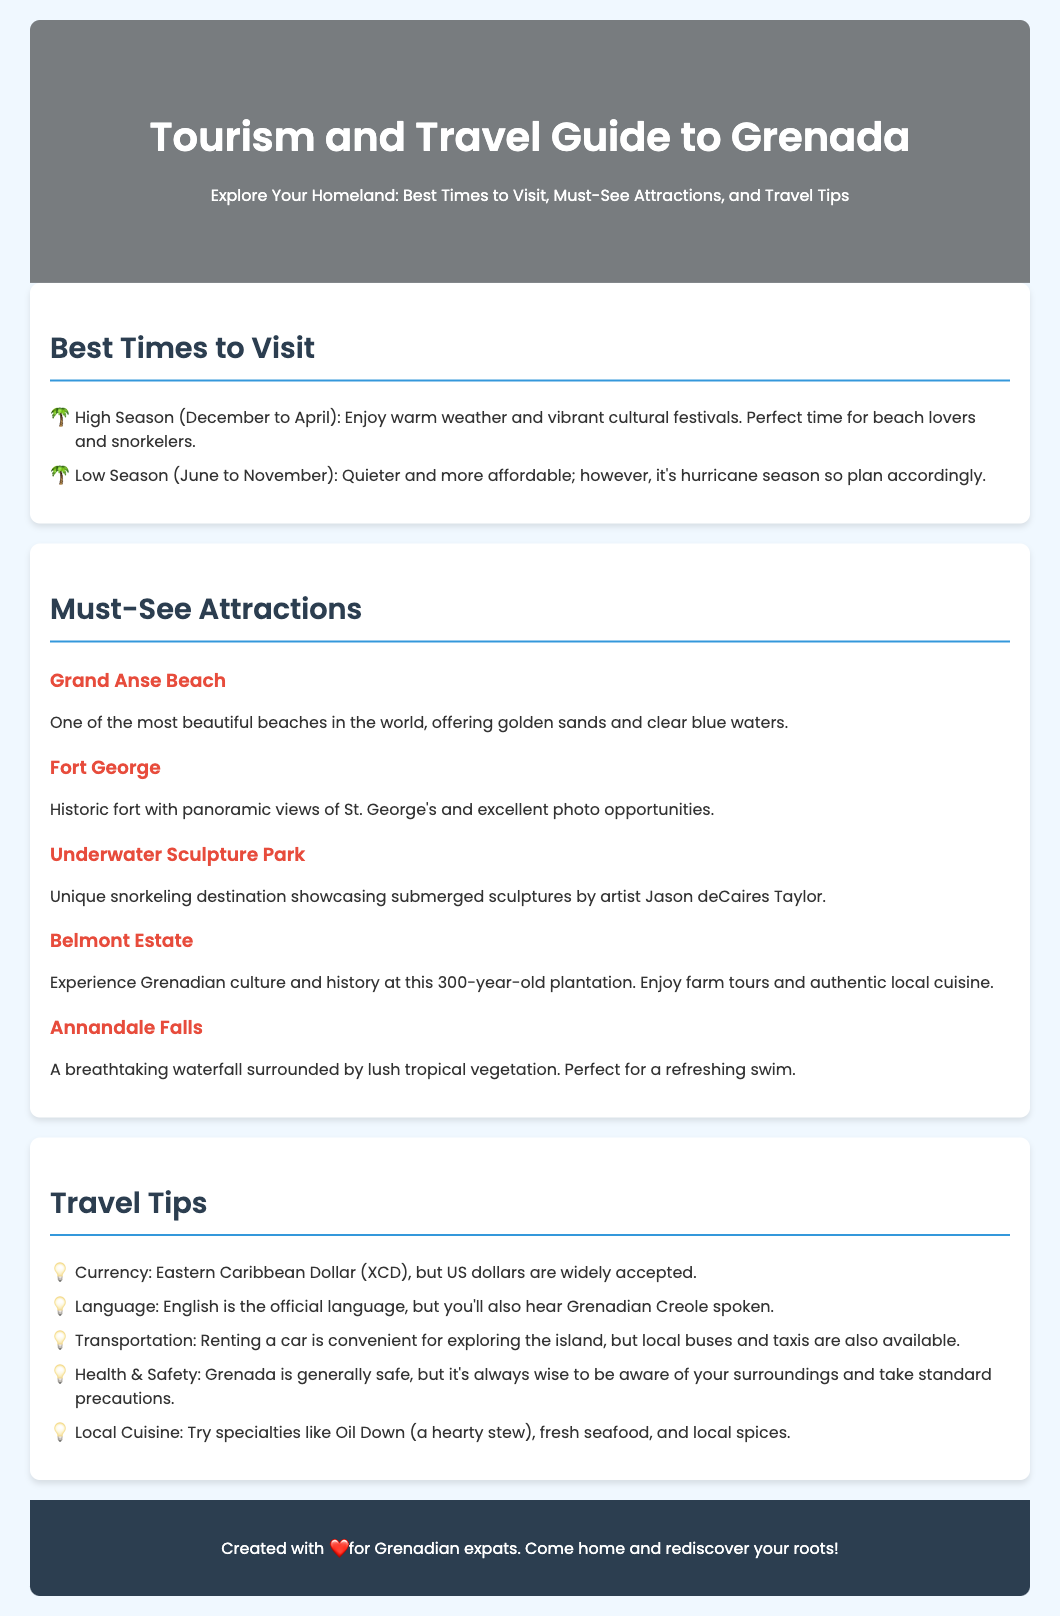What is the high season for visiting Grenada? The high season is from December to April when warm weather and vibrant cultural festivals occur.
Answer: December to April Which beach is noted as one of the most beautiful in the world? Grand Anse Beach is mentioned as one of the most beautiful beaches, offering golden sands and clear blue waters.
Answer: Grand Anse Beach What currency is primarily used in Grenada? The document states that the Eastern Caribbean Dollar (XCD) is the currency, with US dollars widely accepted.
Answer: Eastern Caribbean Dollar What is a specialty dish to try in Grenada? The document highlights Oil Down as a specialty to try, which is a hearty stew.
Answer: Oil Down What should you be aware of regarding health and safety while in Grenada? It mentions that Grenada is generally safe, but it's wise to be aware of your surroundings and take standard precautions.
Answer: Be aware of surroundings What is suggested for better exploring the island of Grenada? Renting a car is suggested as a convenient way to explore the island.
Answer: Renting a car How many must-see attractions are listed in the document? The document lists five must-see attractions in Grenada which showcase various sites to visit.
Answer: Five What is the unique feature of the Underwater Sculpture Park? The Underwater Sculpture Park is a unique snorkeling destination showcasing submerged sculptures by artist Jason deCaires Taylor.
Answer: Submerged sculptures What is the cultural experience offered at Belmont Estate? At Belmont Estate, visitors can experience Grenadian culture and history, including farm tours and authentic local cuisine.
Answer: Farm tours and local cuisine 